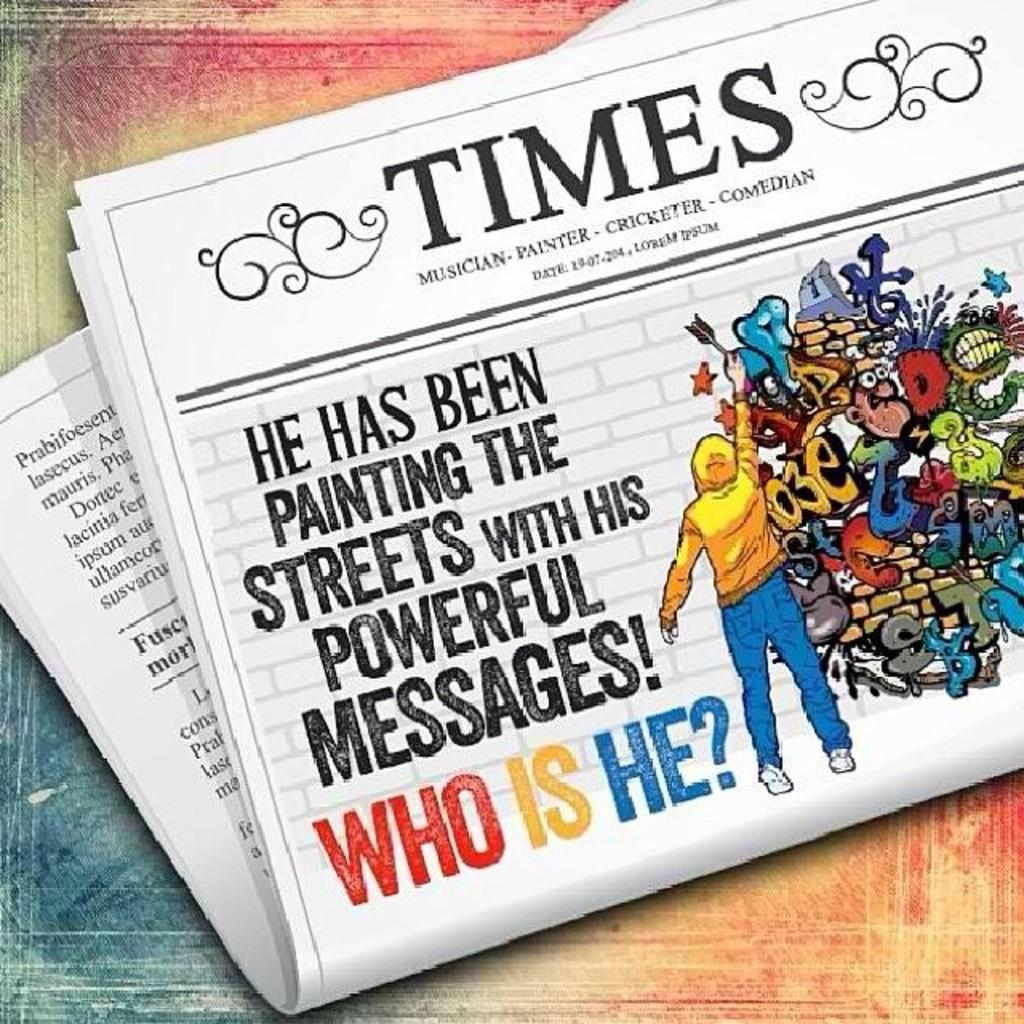Provide a one-sentence caption for the provided image. The cover story of the Times is asking about who the person painting powerful messages is. 